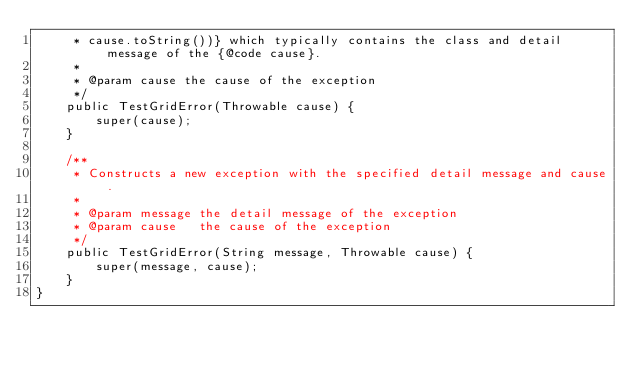Convert code to text. <code><loc_0><loc_0><loc_500><loc_500><_Java_>     * cause.toString())} which typically contains the class and detail message of the {@code cause}.
     *
     * @param cause the cause of the exception
     */
    public TestGridError(Throwable cause) {
        super(cause);
    }

    /**
     * Constructs a new exception with the specified detail message and cause.
     *
     * @param message the detail message of the exception
     * @param cause   the cause of the exception
     */
    public TestGridError(String message, Throwable cause) {
        super(message, cause);
    }
}
</code> 